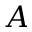Convert formula to latex. <formula><loc_0><loc_0><loc_500><loc_500>A</formula> 